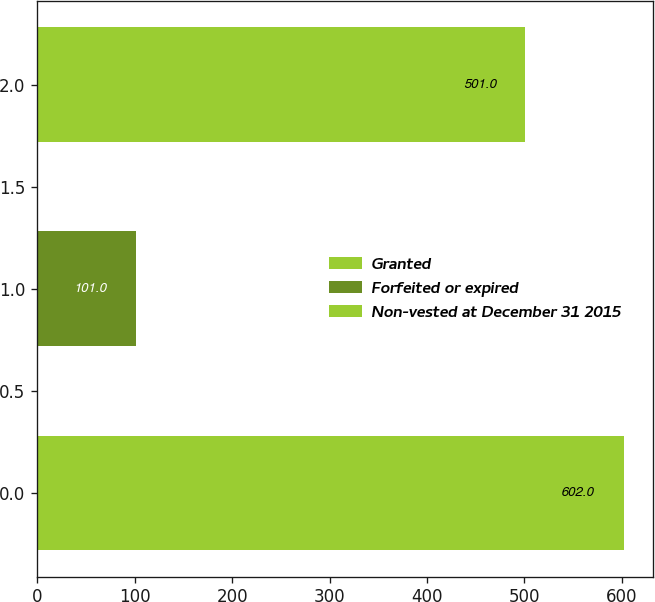<chart> <loc_0><loc_0><loc_500><loc_500><bar_chart><fcel>Granted<fcel>Forfeited or expired<fcel>Non-vested at December 31 2015<nl><fcel>602<fcel>101<fcel>501<nl></chart> 